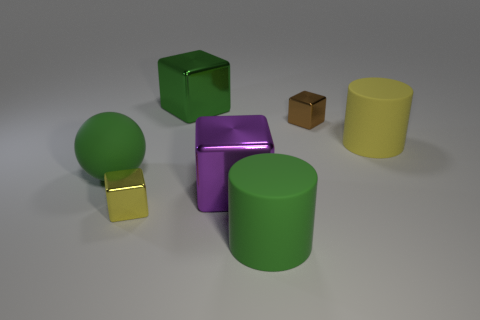Is there a blue rubber cube that has the same size as the ball? Upon reviewing the image, there is no blue cube present; instead, there is a green cube that appears to be close in size to the green ball. However, without proper measurement tools, it cannot be confirmed if they are of the exact same size. 